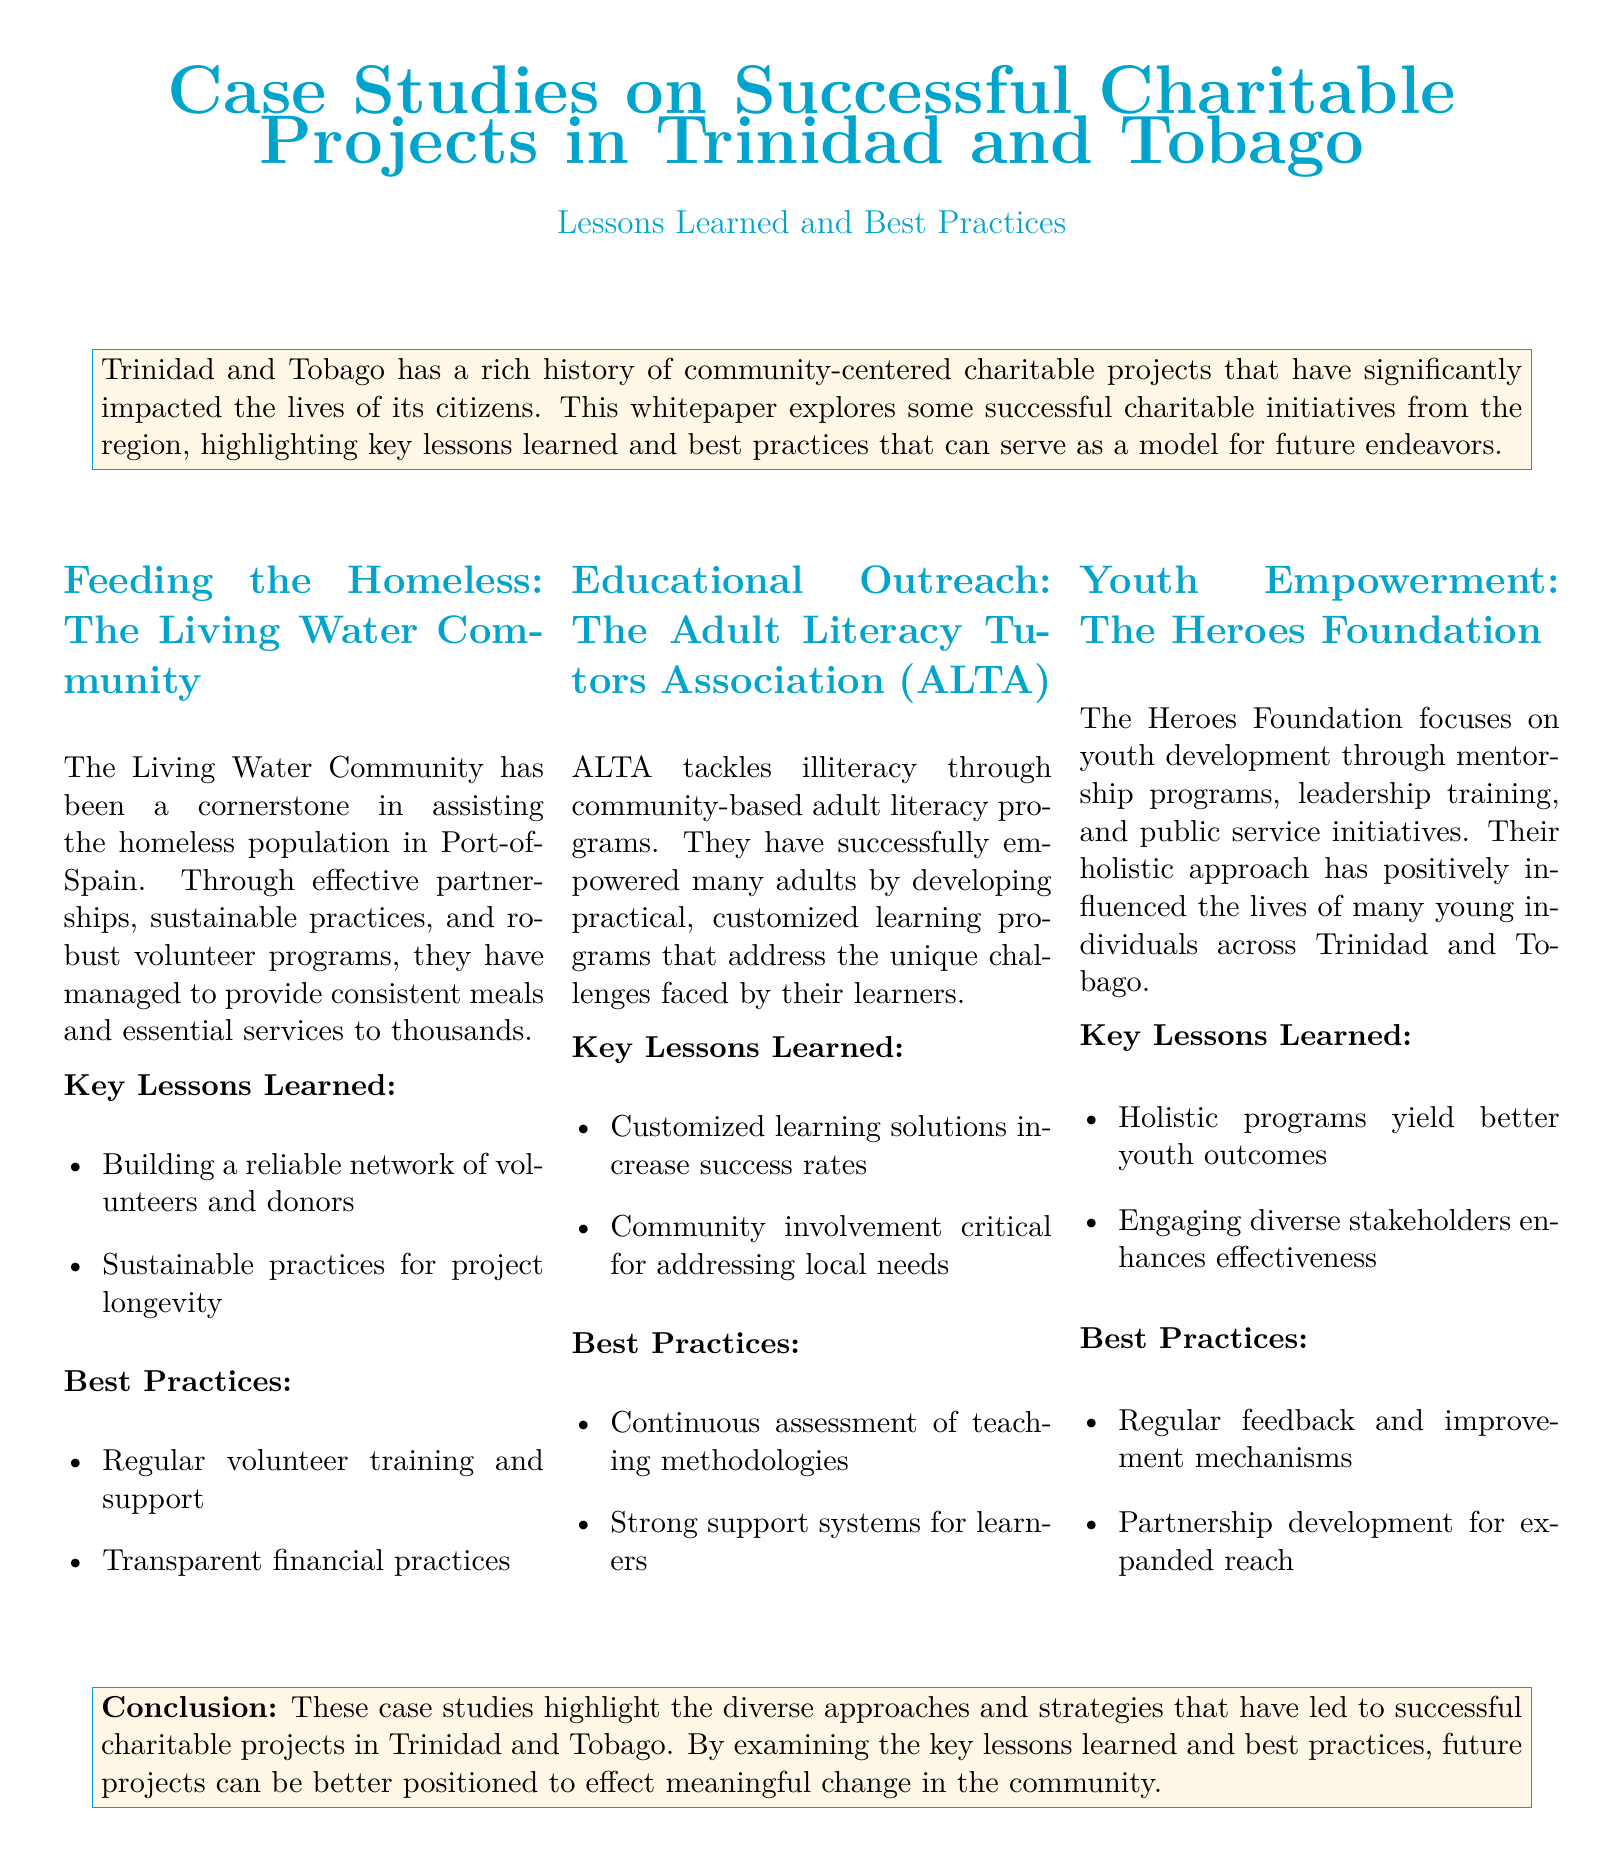What is the focus of the Living Water Community? The Living Water Community focuses on assisting the homeless population in Port-of-Spain.
Answer: assisting the homeless What are the key lessons learned from ALTA? ALTA's key lessons learned include customized learning solutions and community involvement.
Answer: customized learning solutions, community involvement What best practice is highlighted for the Heroes Foundation? A best practice highlighted for the Heroes Foundation is regular feedback and improvement mechanisms.
Answer: regular feedback and improvement mechanisms How does ALTA increase success rates? ALTA increases success rates by developing customized learning solutions that address unique challenges.
Answer: customized learning solutions What is the main theme of the whitepaper? The main theme of the whitepaper is exploring successful charitable initiatives and their lessons learned.
Answer: successful charitable initiatives and lessons learned How many projects are detailed in this whitepaper? The whitepaper details three projects: Living Water Community, ALTA, and Heroes Foundation.
Answer: three projects 